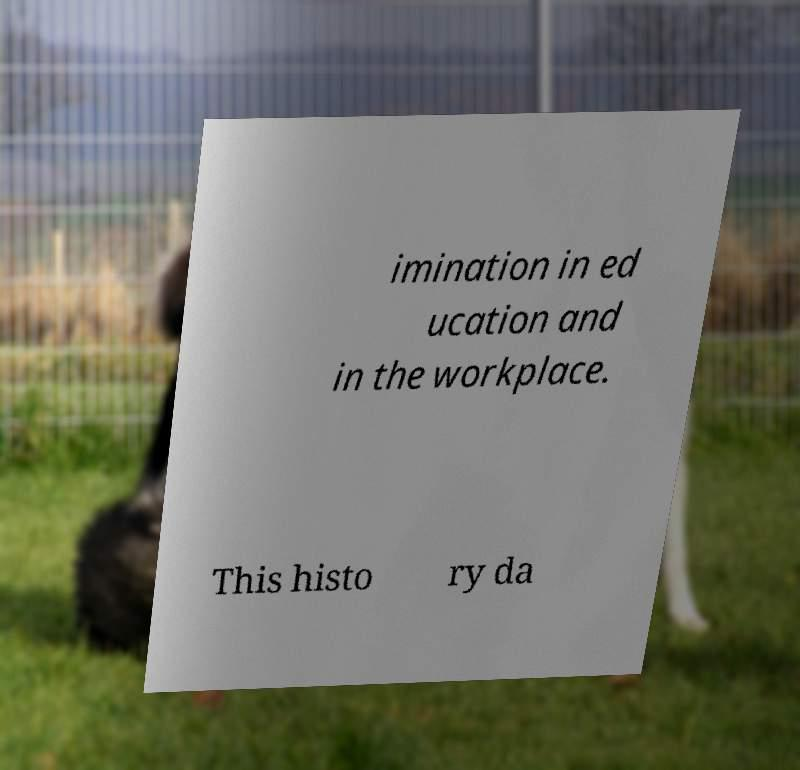Can you read and provide the text displayed in the image?This photo seems to have some interesting text. Can you extract and type it out for me? imination in ed ucation and in the workplace. This histo ry da 